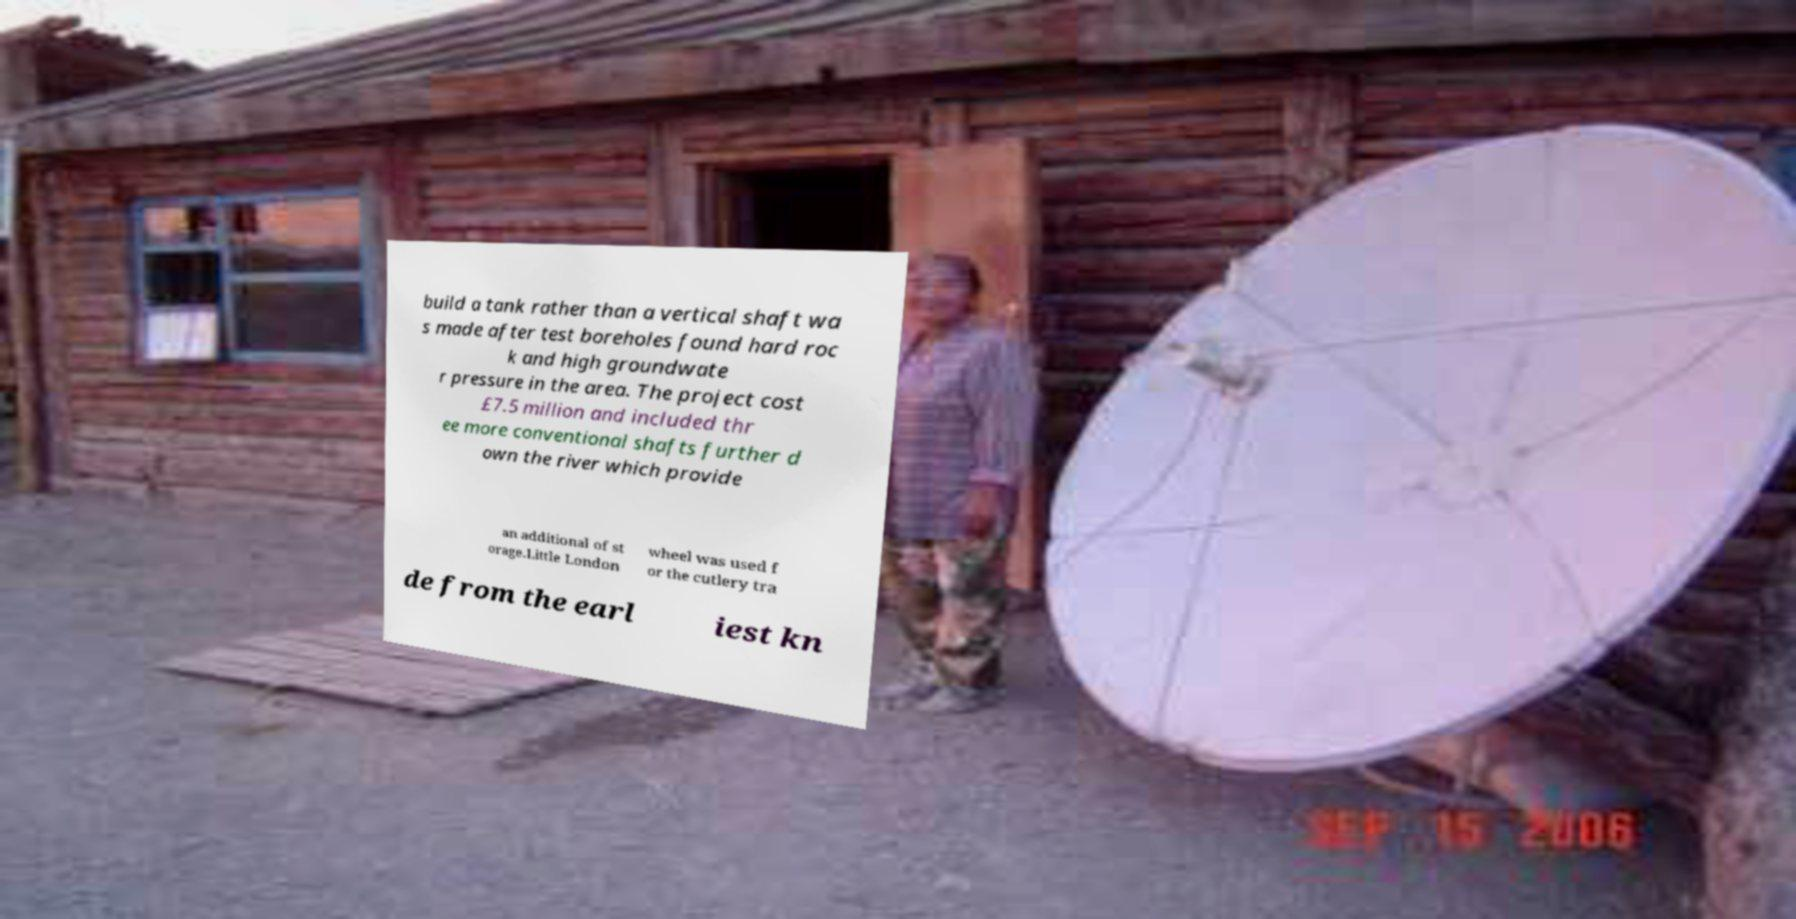There's text embedded in this image that I need extracted. Can you transcribe it verbatim? build a tank rather than a vertical shaft wa s made after test boreholes found hard roc k and high groundwate r pressure in the area. The project cost £7.5 million and included thr ee more conventional shafts further d own the river which provide an additional of st orage.Little London wheel was used f or the cutlery tra de from the earl iest kn 